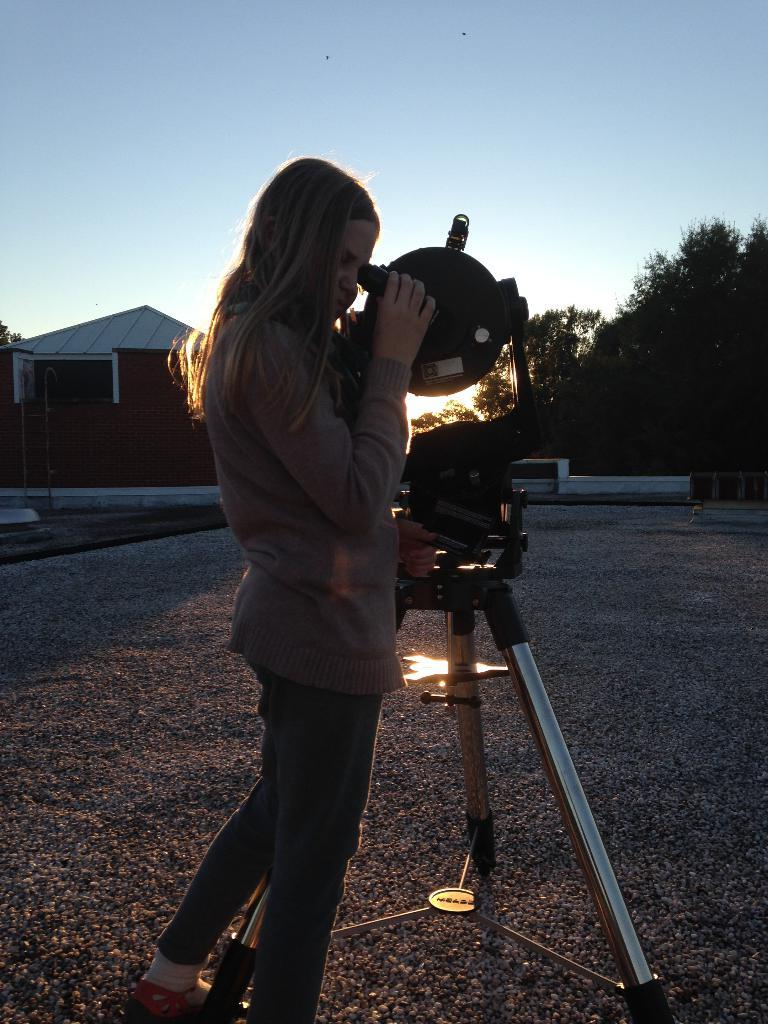Who is the main subject in the image? There is a girl in the image. Where is the girl positioned in the image? The girl is standing in the center of the image. What is the girl doing in the image? The girl is watching through a telescope. What can be seen in the background of the image? There are houses and trees in the background of the image. What is the girl rubbing on the telescope in the image? There is no indication in the image that the girl is rubbing anything on the telescope. 